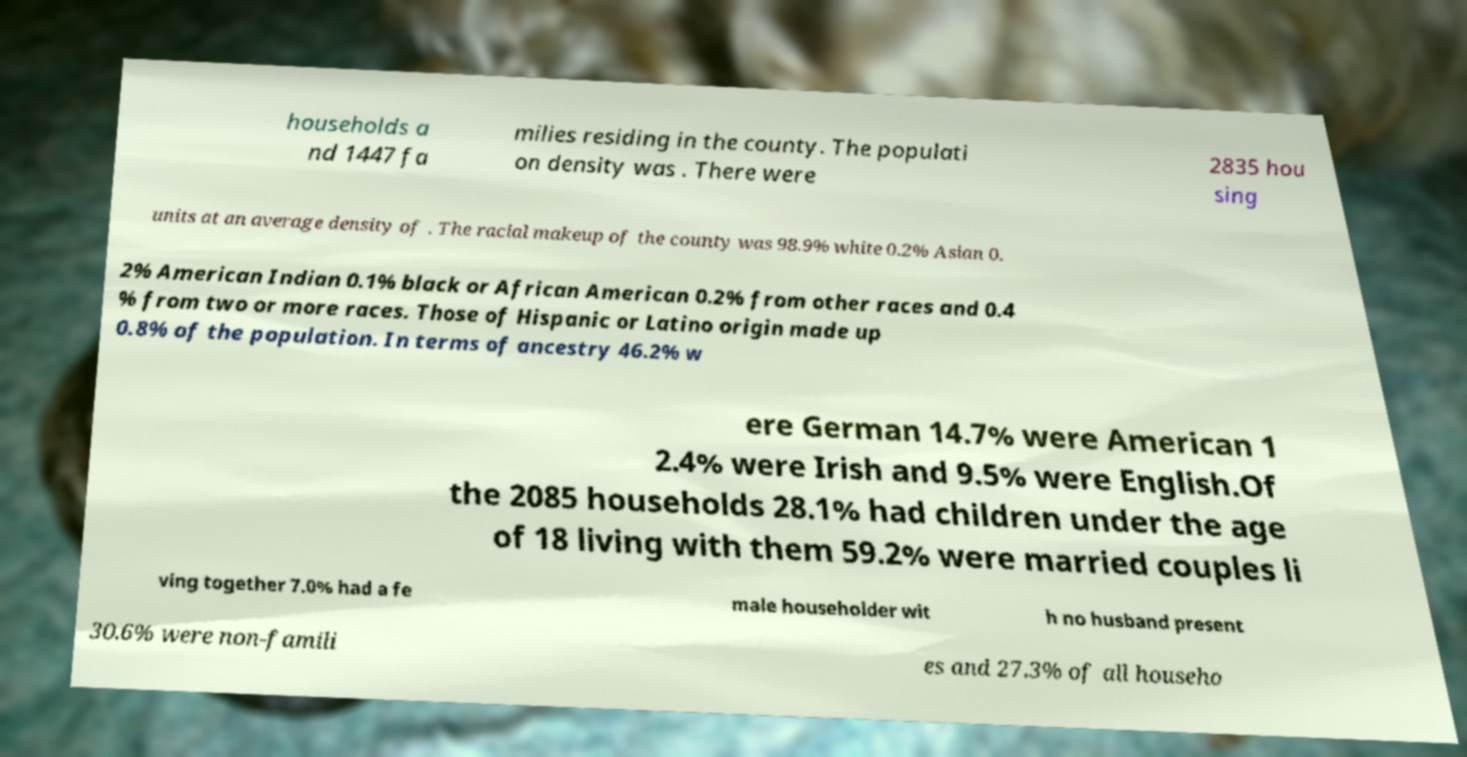I need the written content from this picture converted into text. Can you do that? households a nd 1447 fa milies residing in the county. The populati on density was . There were 2835 hou sing units at an average density of . The racial makeup of the county was 98.9% white 0.2% Asian 0. 2% American Indian 0.1% black or African American 0.2% from other races and 0.4 % from two or more races. Those of Hispanic or Latino origin made up 0.8% of the population. In terms of ancestry 46.2% w ere German 14.7% were American 1 2.4% were Irish and 9.5% were English.Of the 2085 households 28.1% had children under the age of 18 living with them 59.2% were married couples li ving together 7.0% had a fe male householder wit h no husband present 30.6% were non-famili es and 27.3% of all househo 